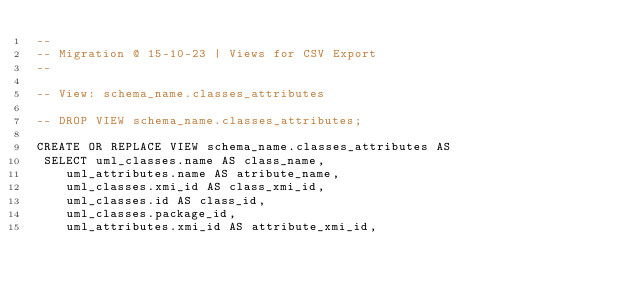Convert code to text. <code><loc_0><loc_0><loc_500><loc_500><_SQL_>--
-- Migration @ 15-10-23 | Views for CSV Export
--
 
-- View: schema_name.classes_attributes

-- DROP VIEW schema_name.classes_attributes;

CREATE OR REPLACE VIEW schema_name.classes_attributes AS 
 SELECT uml_classes.name AS class_name,
    uml_attributes.name AS atribute_name,
    uml_classes.xmi_id AS class_xmi_id,
    uml_classes.id AS class_id,
    uml_classes.package_id,
    uml_attributes.xmi_id AS attribute_xmi_id,</code> 